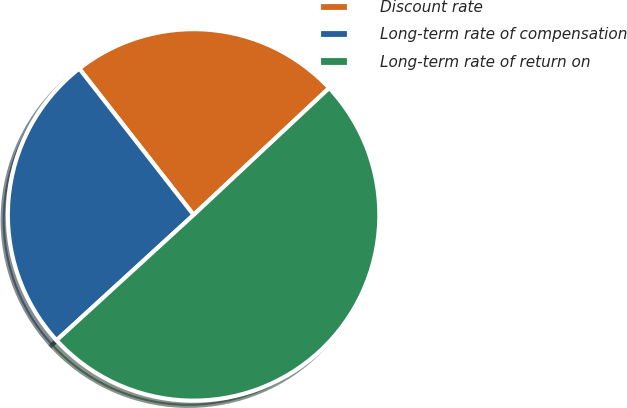Convert chart. <chart><loc_0><loc_0><loc_500><loc_500><pie_chart><fcel>Discount rate<fcel>Long-term rate of compensation<fcel>Long-term rate of return on<nl><fcel>23.58%<fcel>26.24%<fcel>50.18%<nl></chart> 